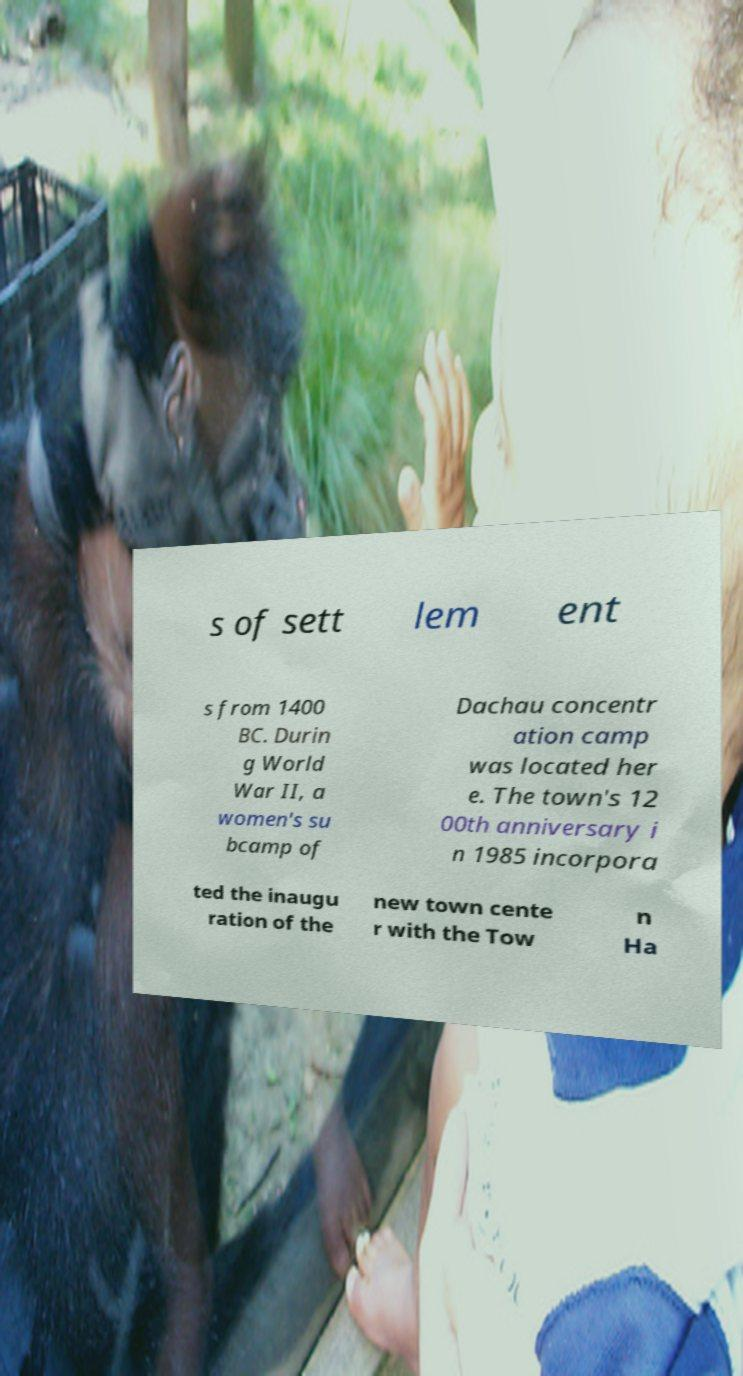What messages or text are displayed in this image? I need them in a readable, typed format. s of sett lem ent s from 1400 BC. Durin g World War II, a women's su bcamp of Dachau concentr ation camp was located her e. The town's 12 00th anniversary i n 1985 incorpora ted the inaugu ration of the new town cente r with the Tow n Ha 